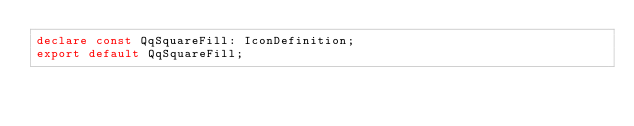Convert code to text. <code><loc_0><loc_0><loc_500><loc_500><_TypeScript_>declare const QqSquareFill: IconDefinition;
export default QqSquareFill;
</code> 